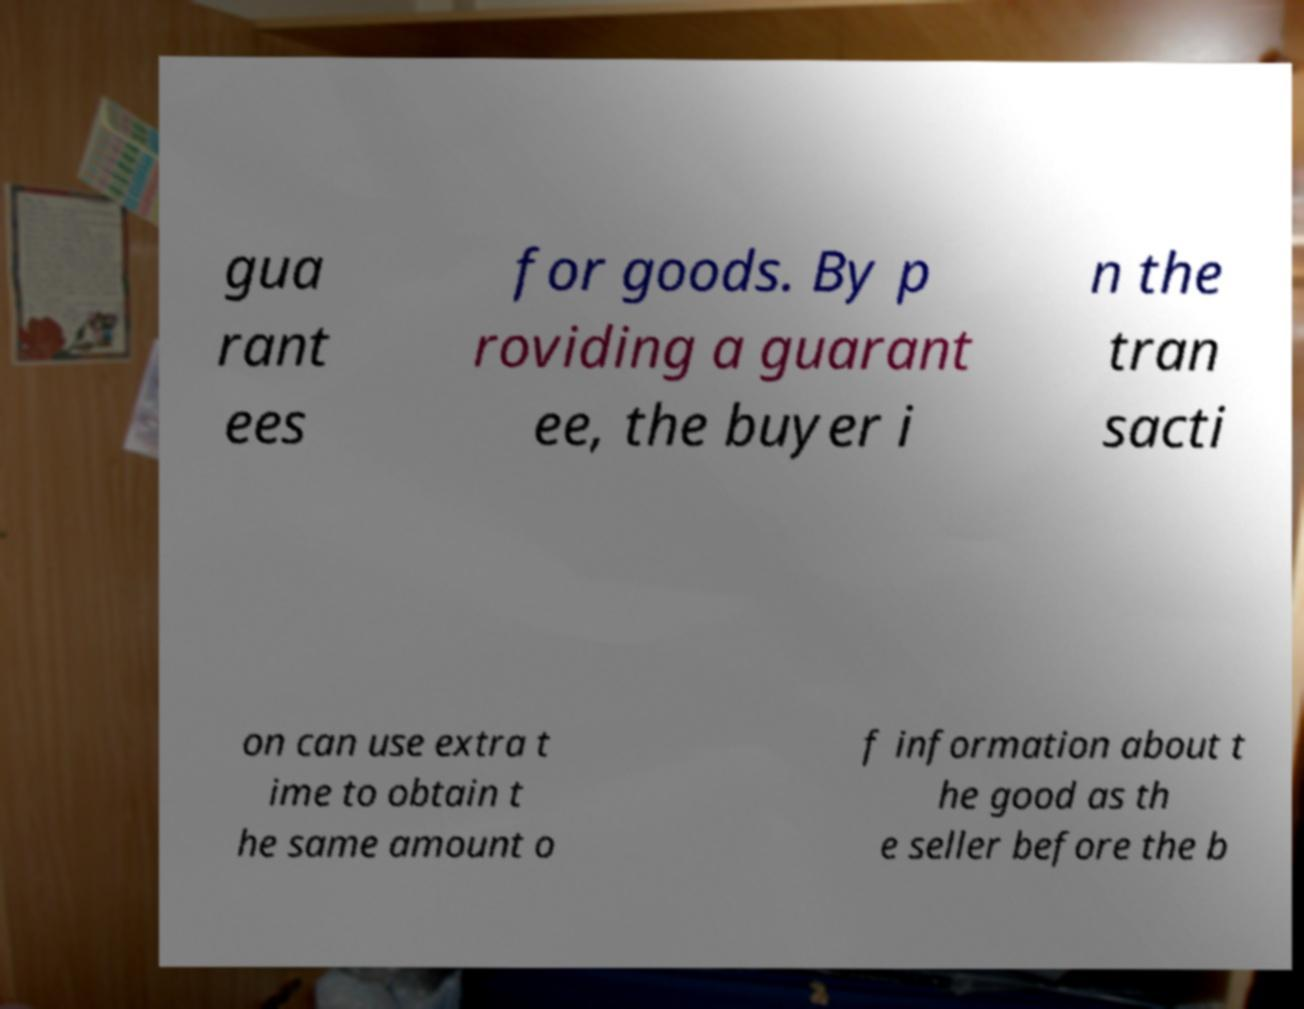I need the written content from this picture converted into text. Can you do that? gua rant ees for goods. By p roviding a guarant ee, the buyer i n the tran sacti on can use extra t ime to obtain t he same amount o f information about t he good as th e seller before the b 